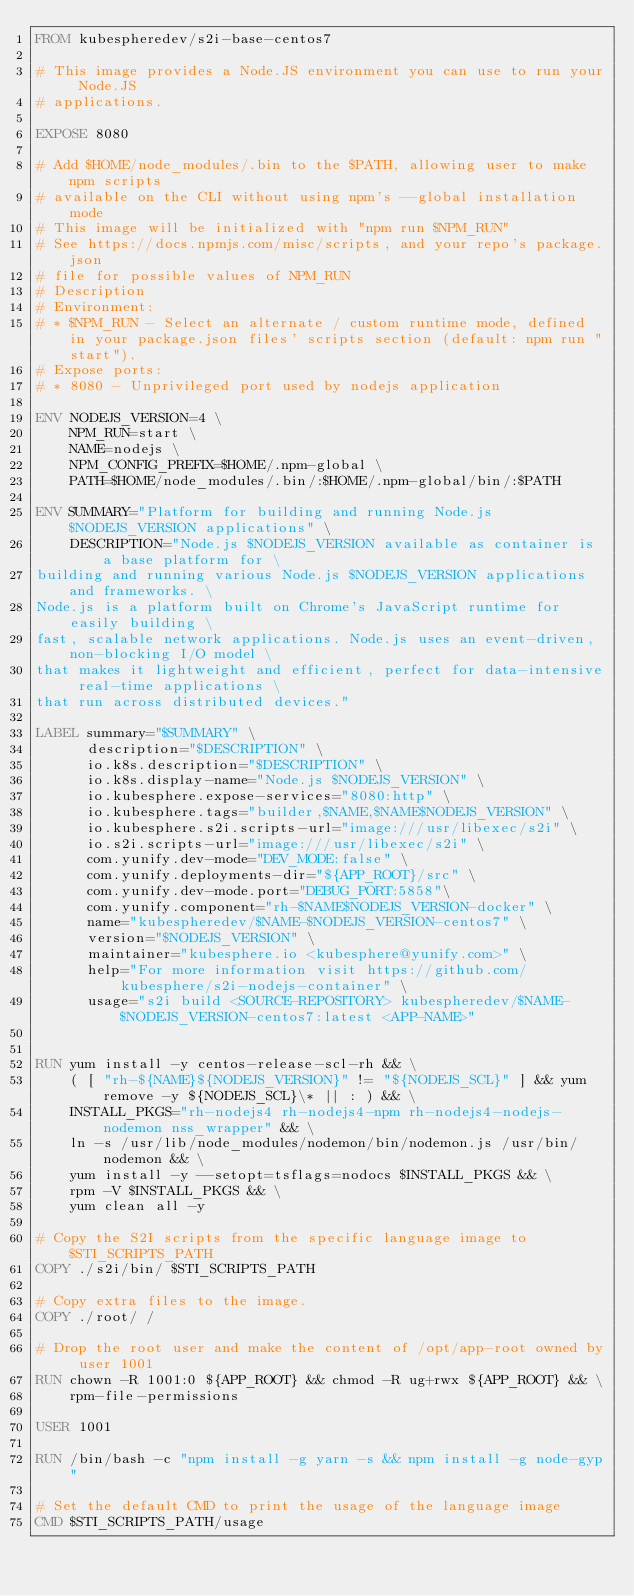Convert code to text. <code><loc_0><loc_0><loc_500><loc_500><_Dockerfile_>FROM kubespheredev/s2i-base-centos7

# This image provides a Node.JS environment you can use to run your Node.JS
# applications.

EXPOSE 8080

# Add $HOME/node_modules/.bin to the $PATH, allowing user to make npm scripts
# available on the CLI without using npm's --global installation mode
# This image will be initialized with "npm run $NPM_RUN"
# See https://docs.npmjs.com/misc/scripts, and your repo's package.json
# file for possible values of NPM_RUN
# Description
# Environment:
# * $NPM_RUN - Select an alternate / custom runtime mode, defined in your package.json files' scripts section (default: npm run "start").
# Expose ports:
# * 8080 - Unprivileged port used by nodejs application

ENV NODEJS_VERSION=4 \
    NPM_RUN=start \
    NAME=nodejs \
    NPM_CONFIG_PREFIX=$HOME/.npm-global \
    PATH=$HOME/node_modules/.bin/:$HOME/.npm-global/bin/:$PATH

ENV SUMMARY="Platform for building and running Node.js $NODEJS_VERSION applications" \
    DESCRIPTION="Node.js $NODEJS_VERSION available as container is a base platform for \
building and running various Node.js $NODEJS_VERSION applications and frameworks. \
Node.js is a platform built on Chrome's JavaScript runtime for easily building \
fast, scalable network applications. Node.js uses an event-driven, non-blocking I/O model \
that makes it lightweight and efficient, perfect for data-intensive real-time applications \
that run across distributed devices."

LABEL summary="$SUMMARY" \
      description="$DESCRIPTION" \
      io.k8s.description="$DESCRIPTION" \
      io.k8s.display-name="Node.js $NODEJS_VERSION" \
      io.kubesphere.expose-services="8080:http" \
      io.kubesphere.tags="builder,$NAME,$NAME$NODEJS_VERSION" \
      io.kubesphere.s2i.scripts-url="image:///usr/libexec/s2i" \
      io.s2i.scripts-url="image:///usr/libexec/s2i" \
      com.yunify.dev-mode="DEV_MODE:false" \
      com.yunify.deployments-dir="${APP_ROOT}/src" \
      com.yunify.dev-mode.port="DEBUG_PORT:5858"\
      com.yunify.component="rh-$NAME$NODEJS_VERSION-docker" \
      name="kubespheredev/$NAME-$NODEJS_VERSION-centos7" \
      version="$NODEJS_VERSION" \
      maintainer="kubesphere.io <kubesphere@yunify.com>" \
      help="For more information visit https://github.com/kubesphere/s2i-nodejs-container" \
      usage="s2i build <SOURCE-REPOSITORY> kubespheredev/$NAME-$NODEJS_VERSION-centos7:latest <APP-NAME>"


RUN yum install -y centos-release-scl-rh && \
    ( [ "rh-${NAME}${NODEJS_VERSION}" != "${NODEJS_SCL}" ] && yum remove -y ${NODEJS_SCL}\* || : ) && \
    INSTALL_PKGS="rh-nodejs4 rh-nodejs4-npm rh-nodejs4-nodejs-nodemon nss_wrapper" && \
    ln -s /usr/lib/node_modules/nodemon/bin/nodemon.js /usr/bin/nodemon && \
    yum install -y --setopt=tsflags=nodocs $INSTALL_PKGS && \
    rpm -V $INSTALL_PKGS && \
    yum clean all -y

# Copy the S2I scripts from the specific language image to $STI_SCRIPTS_PATH
COPY ./s2i/bin/ $STI_SCRIPTS_PATH

# Copy extra files to the image.
COPY ./root/ /

# Drop the root user and make the content of /opt/app-root owned by user 1001
RUN chown -R 1001:0 ${APP_ROOT} && chmod -R ug+rwx ${APP_ROOT} && \
    rpm-file-permissions

USER 1001

RUN /bin/bash -c "npm install -g yarn -s && npm install -g node-gyp"

# Set the default CMD to print the usage of the language image
CMD $STI_SCRIPTS_PATH/usage
</code> 